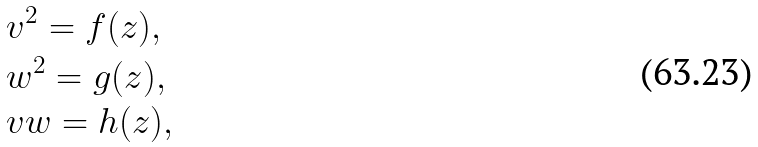<formula> <loc_0><loc_0><loc_500><loc_500>& v ^ { 2 } = f ( z ) , \\ & w ^ { 2 } = g ( z ) , \\ & v w = h ( z ) ,</formula> 